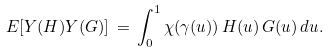Convert formula to latex. <formula><loc_0><loc_0><loc_500><loc_500>E [ Y ( H ) Y ( G ) ] \, = \, \int _ { 0 } ^ { 1 } \chi ( \gamma ( u ) ) \, H ( u ) \, G ( u ) \, d u .</formula> 